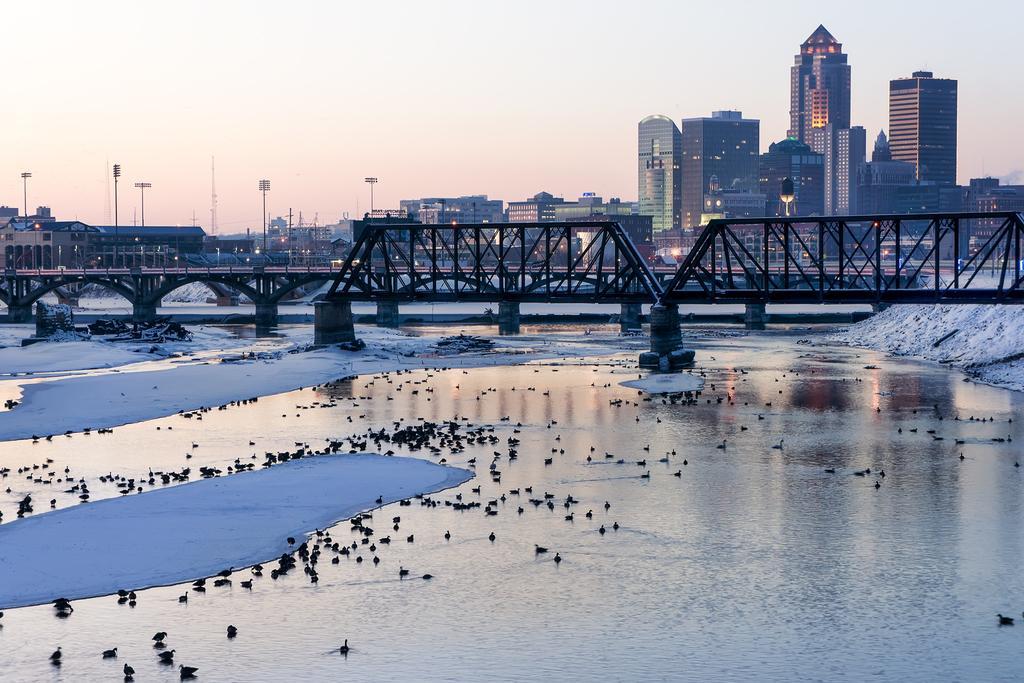In one or two sentences, can you explain what this image depicts? In this image we can see a bridge over the water, there we can see birds and on the water, there we see few buildings, electric poles with lights and the sky. 